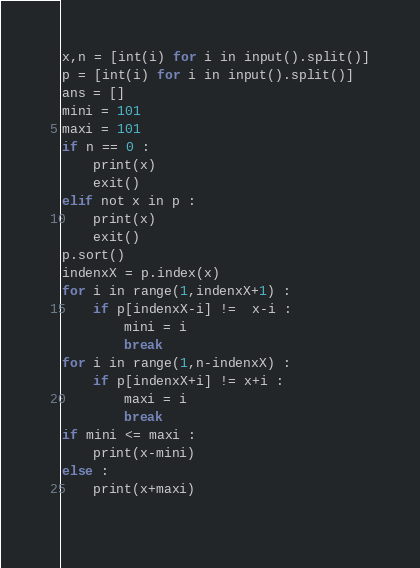Convert code to text. <code><loc_0><loc_0><loc_500><loc_500><_Python_>x,n = [int(i) for i in input().split()]
p = [int(i) for i in input().split()]
ans = []
mini = 101
maxi = 101
if n == 0 :
    print(x)
    exit()
elif not x in p :
    print(x)
    exit()
p.sort()
indenxX = p.index(x)
for i in range(1,indenxX+1) :
    if p[indenxX-i] !=  x-i :
        mini = i
        break
for i in range(1,n-indenxX) :
    if p[indenxX+i] != x+i :
        maxi = i
        break
if mini <= maxi :
    print(x-mini)
else :
    print(x+maxi)
    </code> 